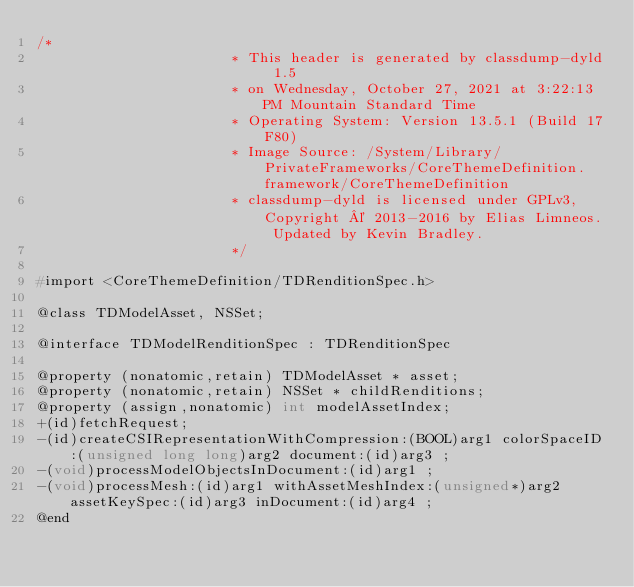Convert code to text. <code><loc_0><loc_0><loc_500><loc_500><_C_>/*
                       * This header is generated by classdump-dyld 1.5
                       * on Wednesday, October 27, 2021 at 3:22:13 PM Mountain Standard Time
                       * Operating System: Version 13.5.1 (Build 17F80)
                       * Image Source: /System/Library/PrivateFrameworks/CoreThemeDefinition.framework/CoreThemeDefinition
                       * classdump-dyld is licensed under GPLv3, Copyright © 2013-2016 by Elias Limneos. Updated by Kevin Bradley.
                       */

#import <CoreThemeDefinition/TDRenditionSpec.h>

@class TDModelAsset, NSSet;

@interface TDModelRenditionSpec : TDRenditionSpec

@property (nonatomic,retain) TDModelAsset * asset; 
@property (nonatomic,retain) NSSet * childRenditions; 
@property (assign,nonatomic) int modelAssetIndex; 
+(id)fetchRequest;
-(id)createCSIRepresentationWithCompression:(BOOL)arg1 colorSpaceID:(unsigned long long)arg2 document:(id)arg3 ;
-(void)processModelObjectsInDocument:(id)arg1 ;
-(void)processMesh:(id)arg1 withAssetMeshIndex:(unsigned*)arg2 assetKeySpec:(id)arg3 inDocument:(id)arg4 ;
@end

</code> 